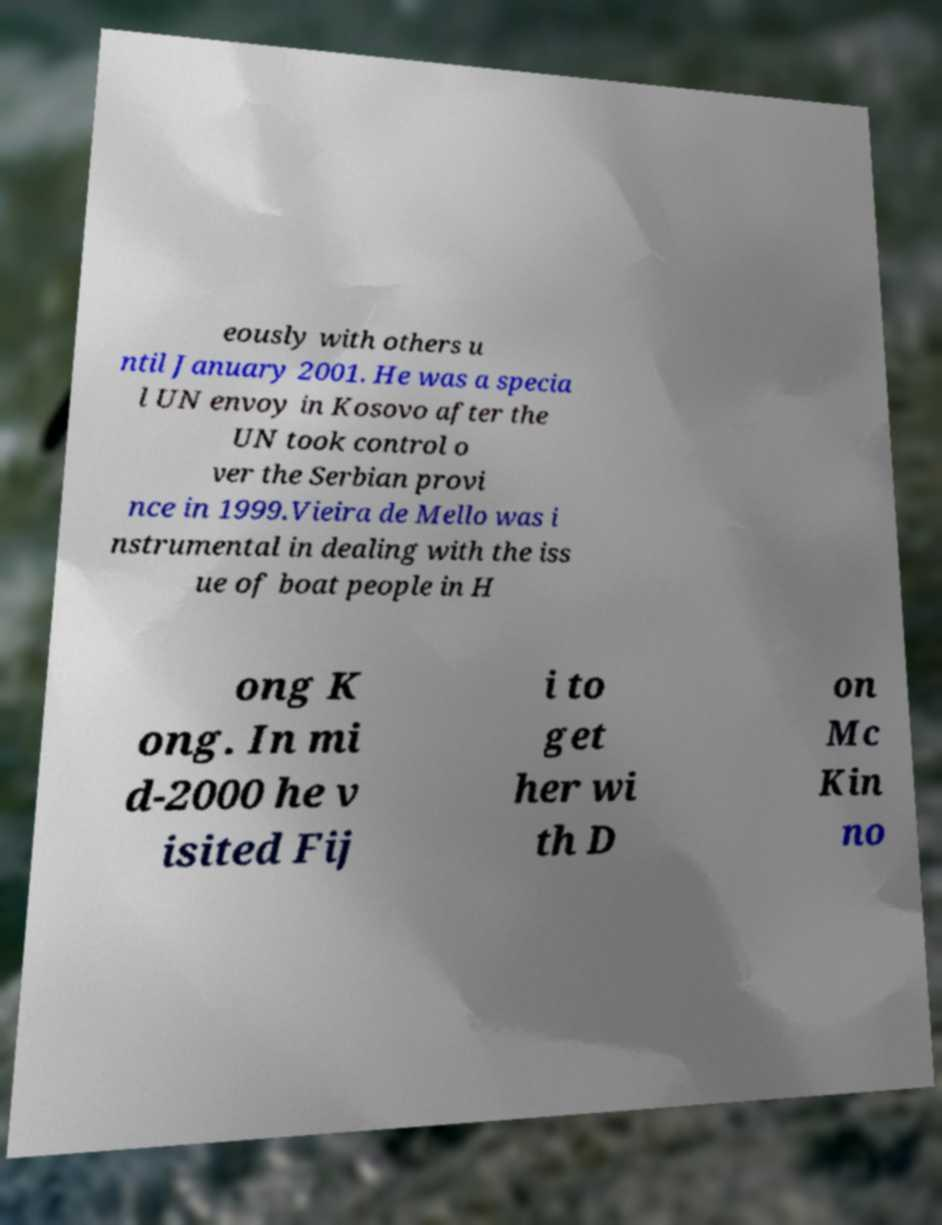Please read and relay the text visible in this image. What does it say? eously with others u ntil January 2001. He was a specia l UN envoy in Kosovo after the UN took control o ver the Serbian provi nce in 1999.Vieira de Mello was i nstrumental in dealing with the iss ue of boat people in H ong K ong. In mi d-2000 he v isited Fij i to get her wi th D on Mc Kin no 